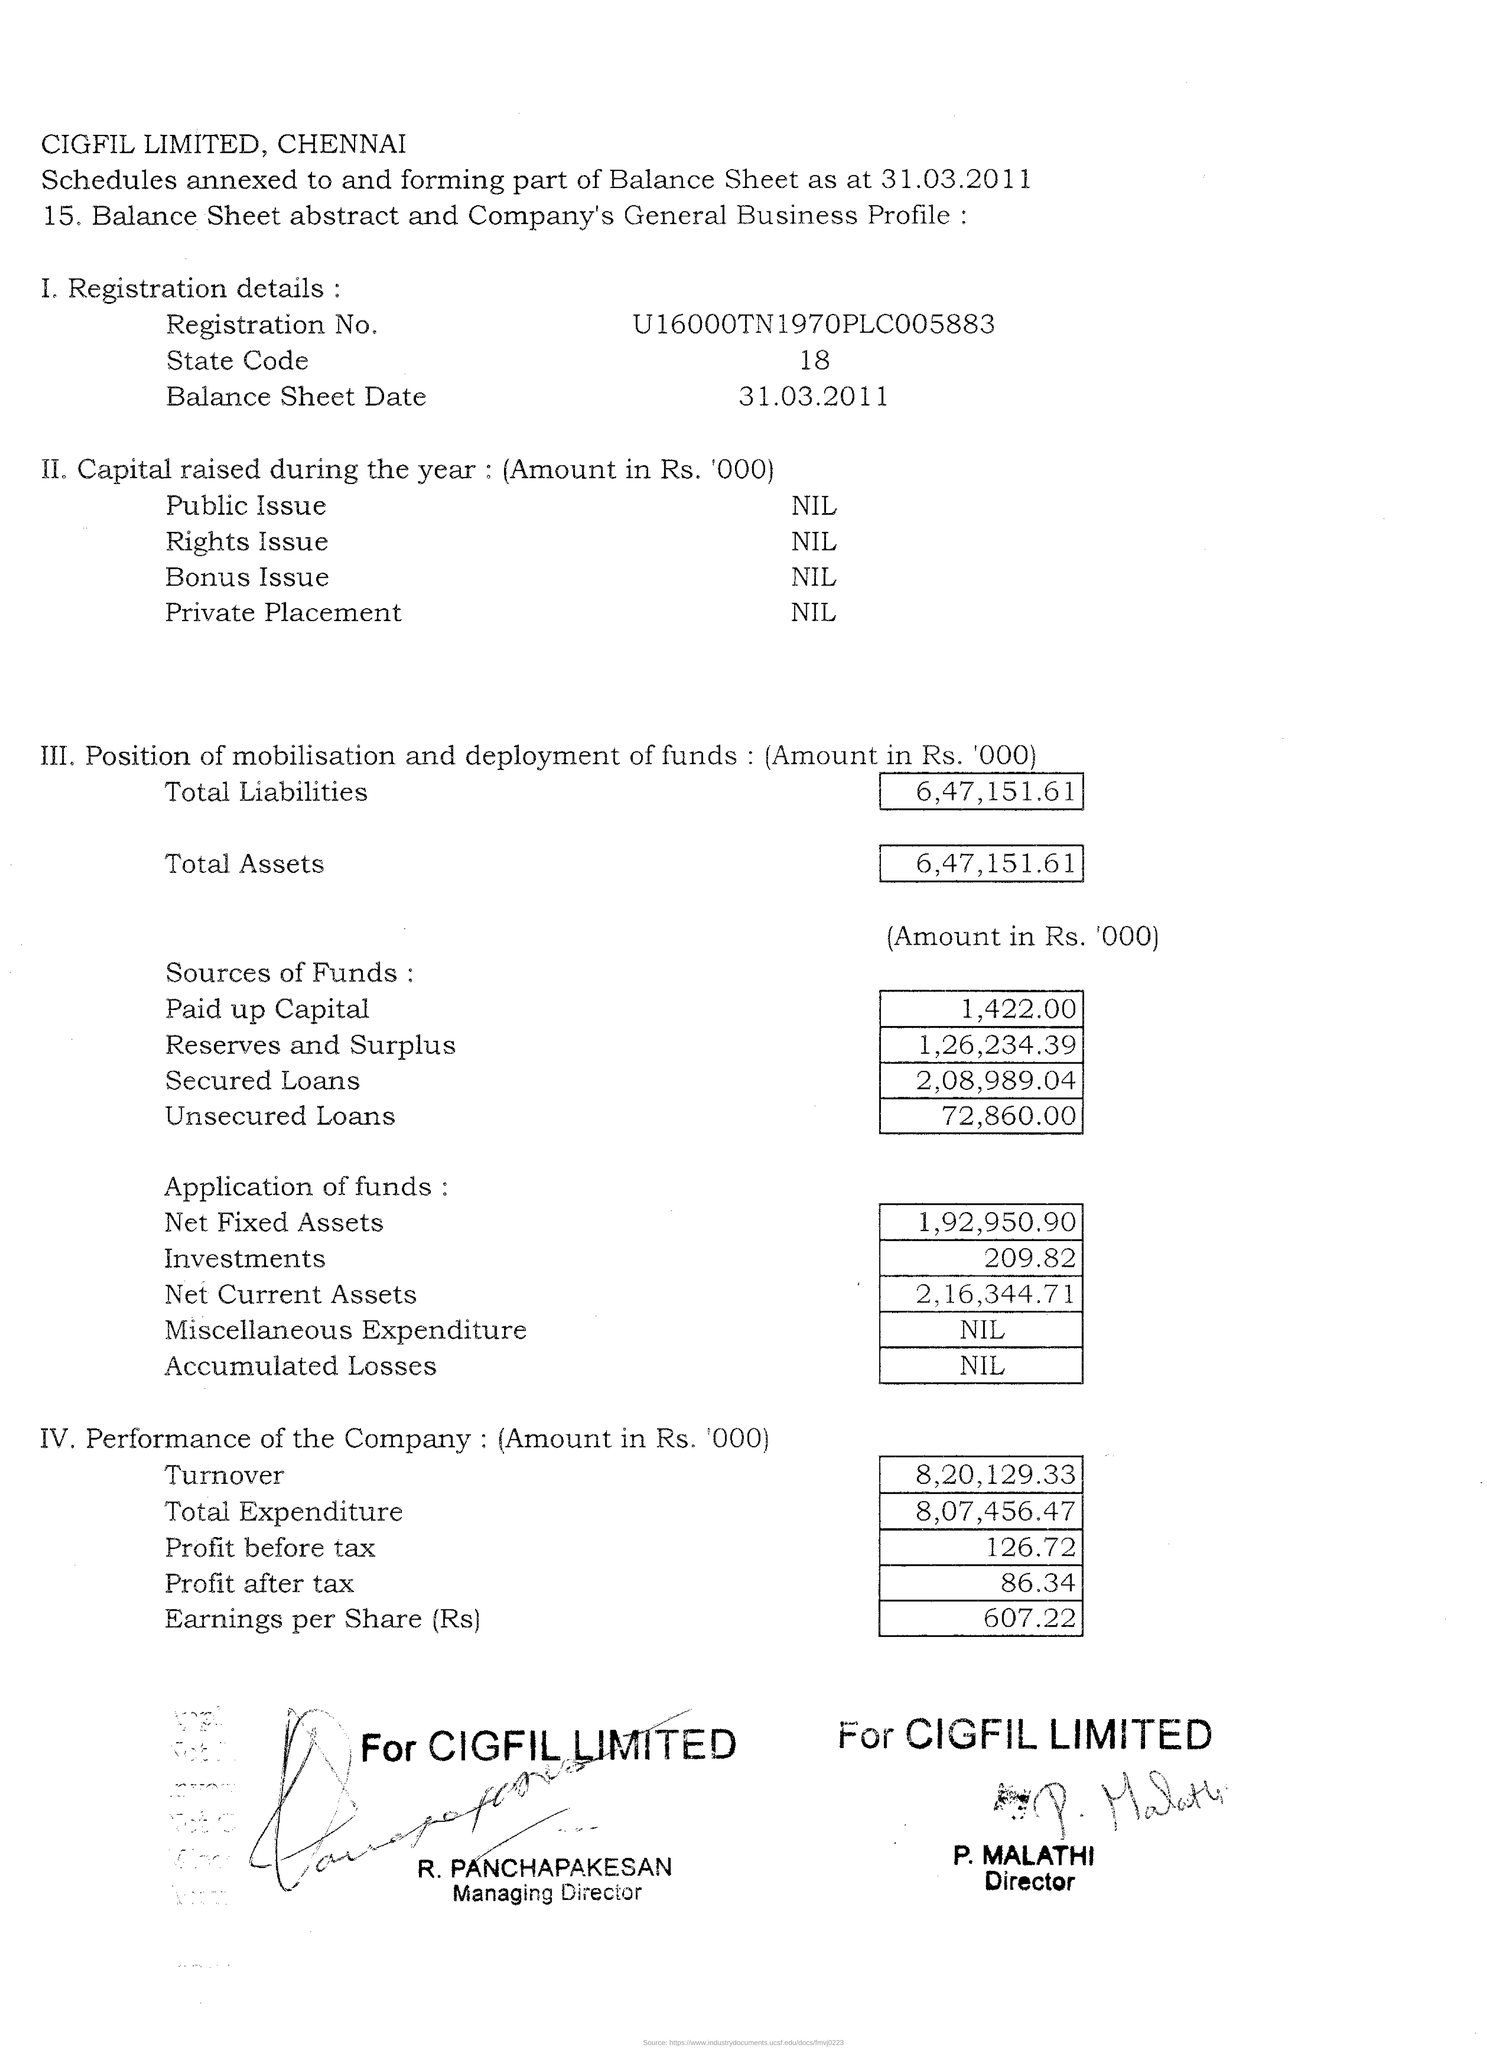Mention a couple of crucial points in this snapshot. The state code is 18.. The total expenditure of the company is 8,07,456.47. On the balance sheet date of 31.03.2011, the balance sheet was prepared. The turnover of the company is 8,20,129.33. The company's registration number is U16000TN1970PLC005883... 